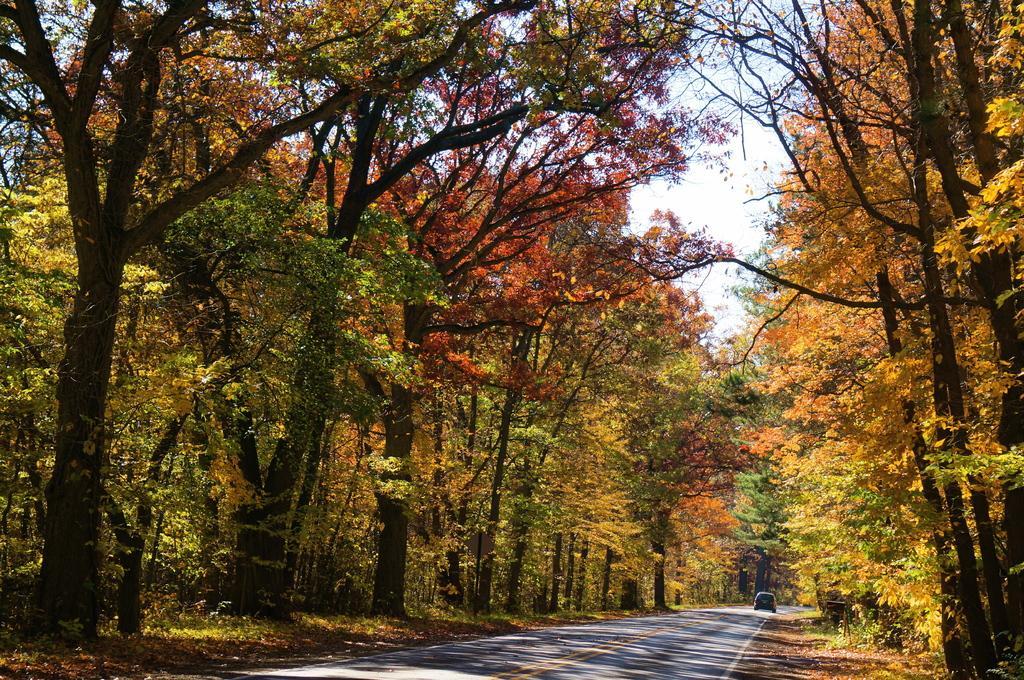Describe this image in one or two sentences. In the foreground of this image, there is a road on which there is a vehicle. On either side, there are trees and at the top, there is the sky. 